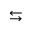<formula> <loc_0><loc_0><loc_500><loc_500>\leftrightarrow s</formula> 